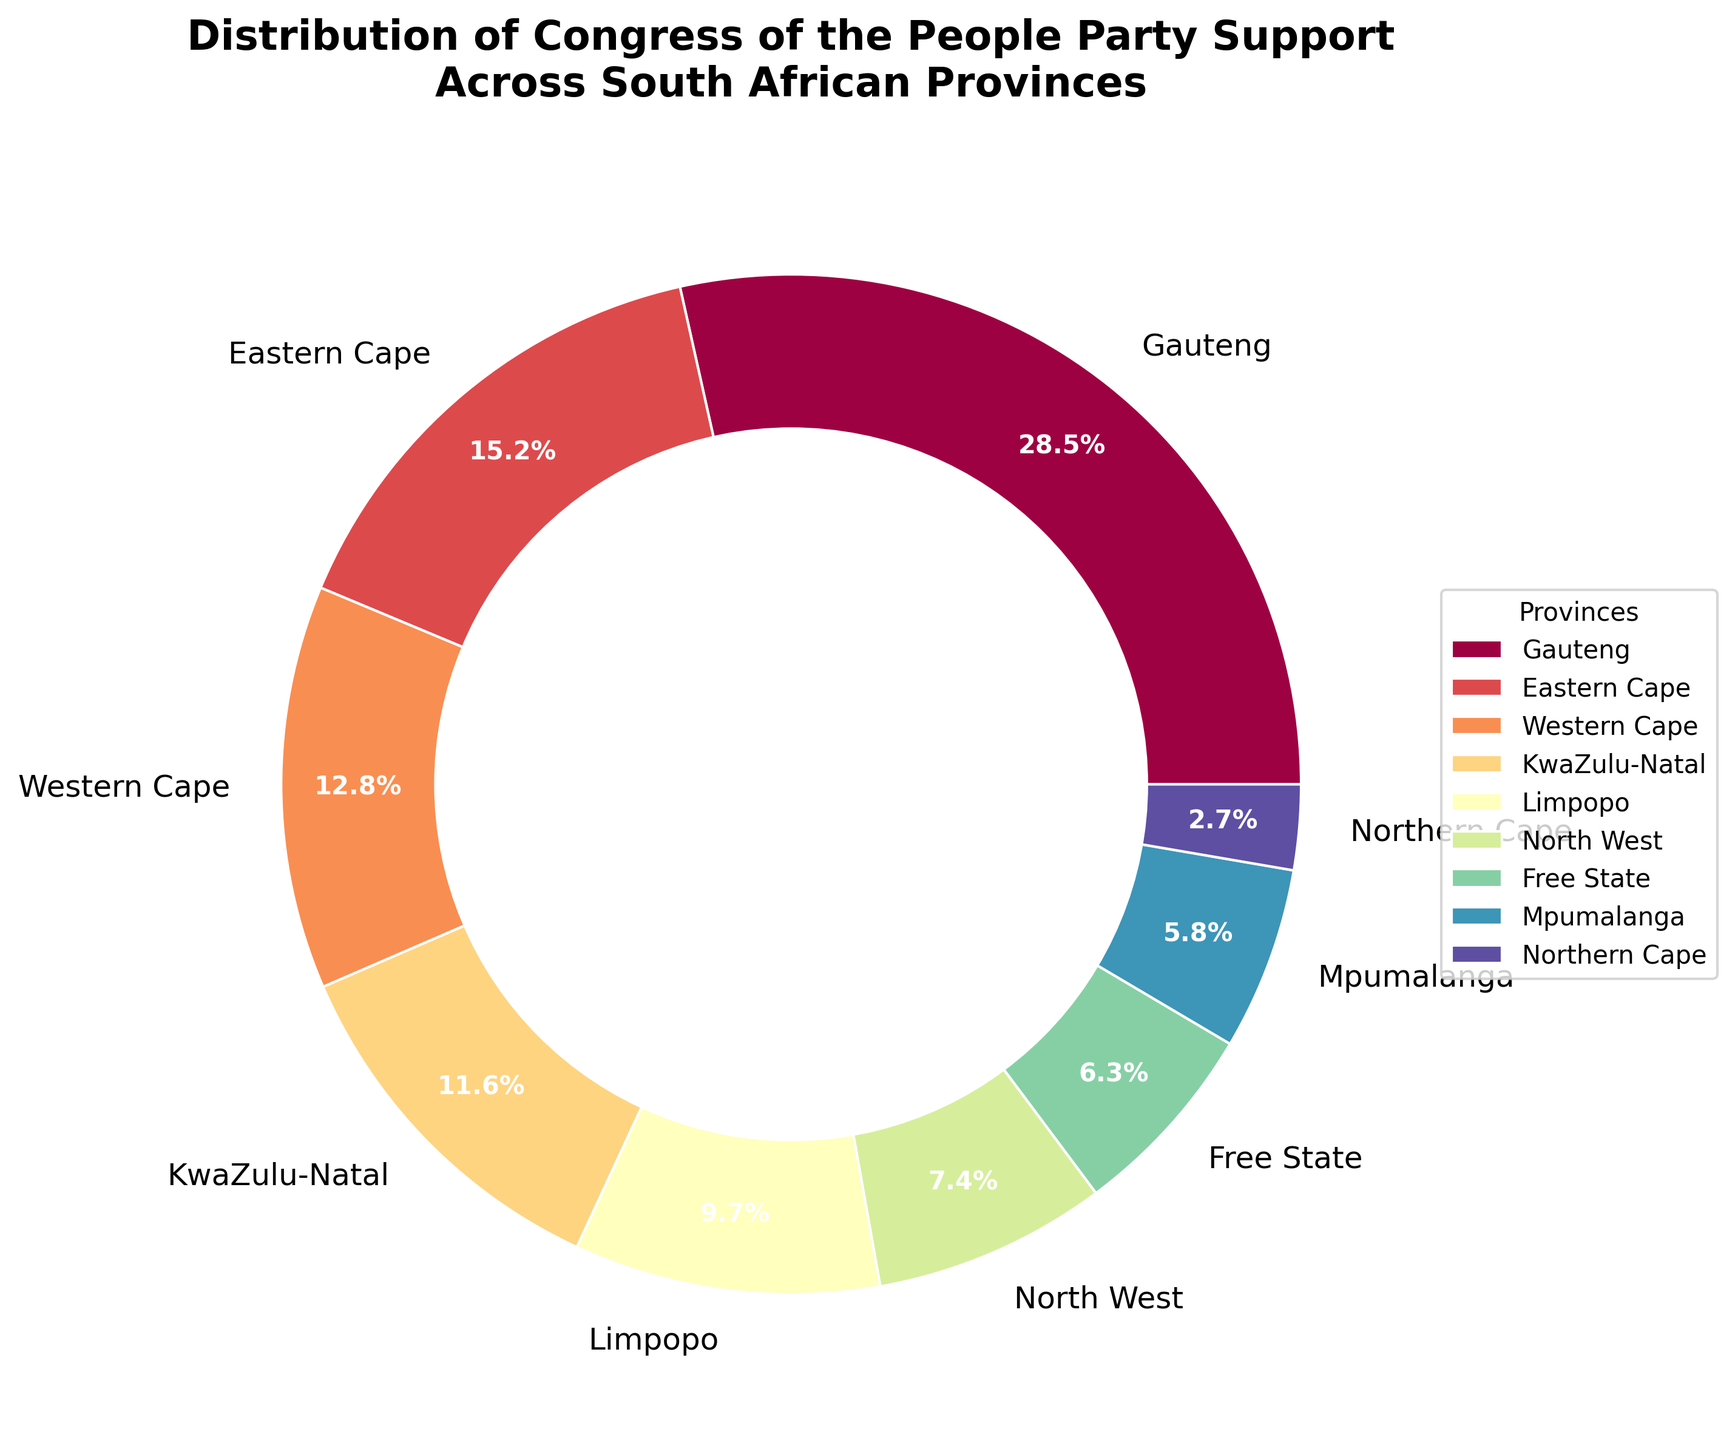What province has the highest support percentage for the Congress of the People party? The pie chart shows different provinces with their corresponding support percentages. Gauteng has the largest pie slice indicating the highest support percentage.
Answer: Gauteng What is the combined support percentage of Eastern Cape and Western Cape? From the chart, the support percentages for Eastern Cape and Western Cape are 15.2% and 12.8%, respectively. Adding them together gives 15.2% + 12.8% = 28%.
Answer: 28% Which province shows the lowest support percentage? The pie chart's smallest slice represents Northern Cape with a support percentage of 2.7%.
Answer: Northern Cape Is the support percentage in KwaZulu-Natal greater than that in North West? The pie chart shows KwaZulu-Natal at 11.6% and North West at 7.4%. Since 11.6% is greater than 7.4%, KwaZulu-Natal has a greater support percentage.
Answer: Yes What is the difference in support percentage between Limpopo and Mpumalanga? The pie chart indicates Limpopo at 9.7% and Mpumalanga at 5.8%. Subtracting these gives 9.7% - 5.8% = 3.9%.
Answer: 3.9% How many provinces have a support percentage above 10%? By examining each segment, Gauteng, Eastern Cape, Western Cape, and KwaZulu-Natal all have support percentages above 10%. The total is 4 provinces.
Answer: 4 Which provinces have similar support percentages? According to the chart, the Free State at 6.3% and Mpumalanga at 5.8% have similar support percentages, with a difference of only 0.5%.
Answer: Free State and Mpumalanga Is the support from Gauteng more than the combined support from Free State, Mpumalanga, and Northern Cape? Gauteng has 28.5%. Adding Free State (6.3%), Mpumalanga (5.8%), and Northern Cape (2.7%) gives 6.3% + 5.8% + 2.7% = 14.8%, which is less than 28.5%.
Answer: Yes What is the support percentage for the Congress of the People party in provinces outside Gauteng and Eastern Cape? The total support without Gauteng (28.5%) and Eastern Cape (15.2%) is obtained by subtracting their sum from 100%. Thus, 100% - (28.5% + 15.2%) = 56.3%.
Answer: 56.3% 